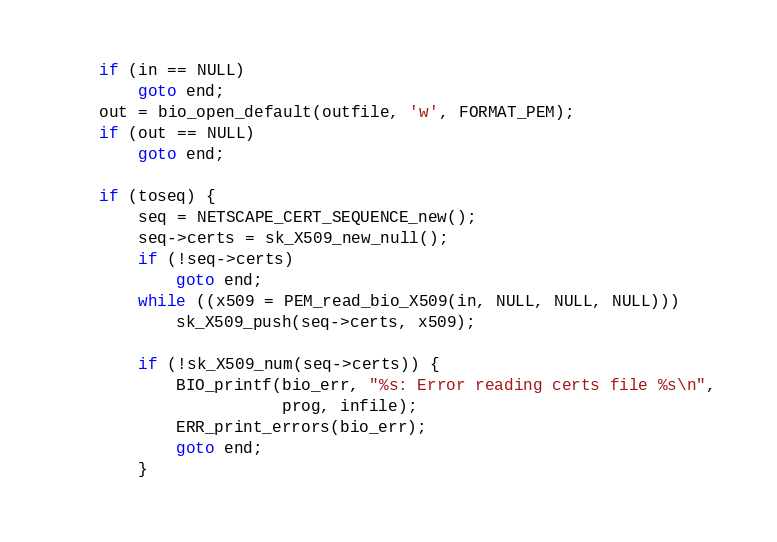Convert code to text. <code><loc_0><loc_0><loc_500><loc_500><_C_>    if (in == NULL)
        goto end;
    out = bio_open_default(outfile, 'w', FORMAT_PEM);
    if (out == NULL)
        goto end;

    if (toseq) {
        seq = NETSCAPE_CERT_SEQUENCE_new();
        seq->certs = sk_X509_new_null();
        if (!seq->certs)
            goto end;
        while ((x509 = PEM_read_bio_X509(in, NULL, NULL, NULL)))
            sk_X509_push(seq->certs, x509);

        if (!sk_X509_num(seq->certs)) {
            BIO_printf(bio_err, "%s: Error reading certs file %s\n",
                       prog, infile);
            ERR_print_errors(bio_err);
            goto end;
        }</code> 